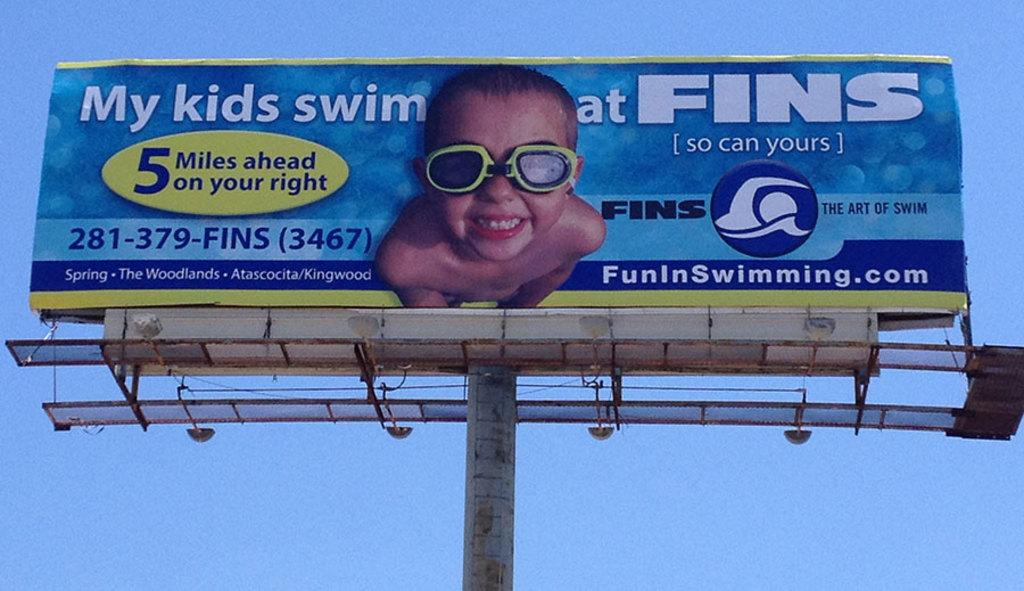<image>
Give a short and clear explanation of the subsequent image. A giant billboard for Fins Swimming featuring a young boy. 